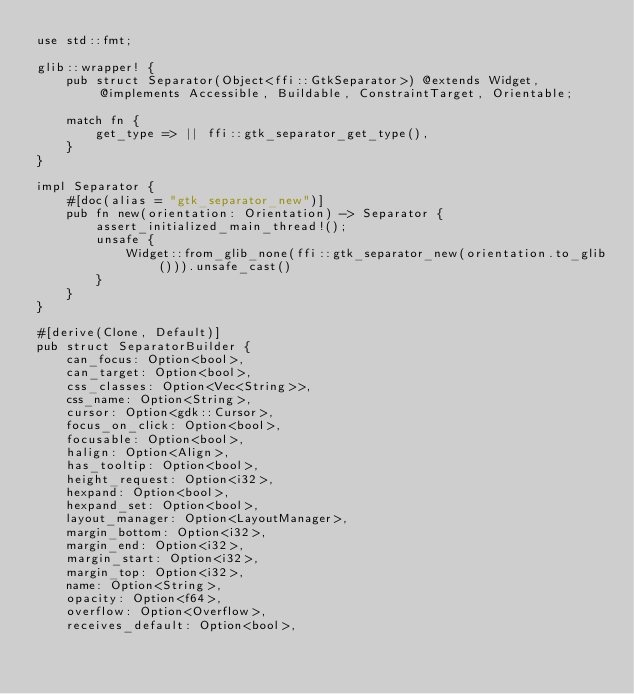<code> <loc_0><loc_0><loc_500><loc_500><_Rust_>use std::fmt;

glib::wrapper! {
    pub struct Separator(Object<ffi::GtkSeparator>) @extends Widget, @implements Accessible, Buildable, ConstraintTarget, Orientable;

    match fn {
        get_type => || ffi::gtk_separator_get_type(),
    }
}

impl Separator {
    #[doc(alias = "gtk_separator_new")]
    pub fn new(orientation: Orientation) -> Separator {
        assert_initialized_main_thread!();
        unsafe {
            Widget::from_glib_none(ffi::gtk_separator_new(orientation.to_glib())).unsafe_cast()
        }
    }
}

#[derive(Clone, Default)]
pub struct SeparatorBuilder {
    can_focus: Option<bool>,
    can_target: Option<bool>,
    css_classes: Option<Vec<String>>,
    css_name: Option<String>,
    cursor: Option<gdk::Cursor>,
    focus_on_click: Option<bool>,
    focusable: Option<bool>,
    halign: Option<Align>,
    has_tooltip: Option<bool>,
    height_request: Option<i32>,
    hexpand: Option<bool>,
    hexpand_set: Option<bool>,
    layout_manager: Option<LayoutManager>,
    margin_bottom: Option<i32>,
    margin_end: Option<i32>,
    margin_start: Option<i32>,
    margin_top: Option<i32>,
    name: Option<String>,
    opacity: Option<f64>,
    overflow: Option<Overflow>,
    receives_default: Option<bool>,</code> 